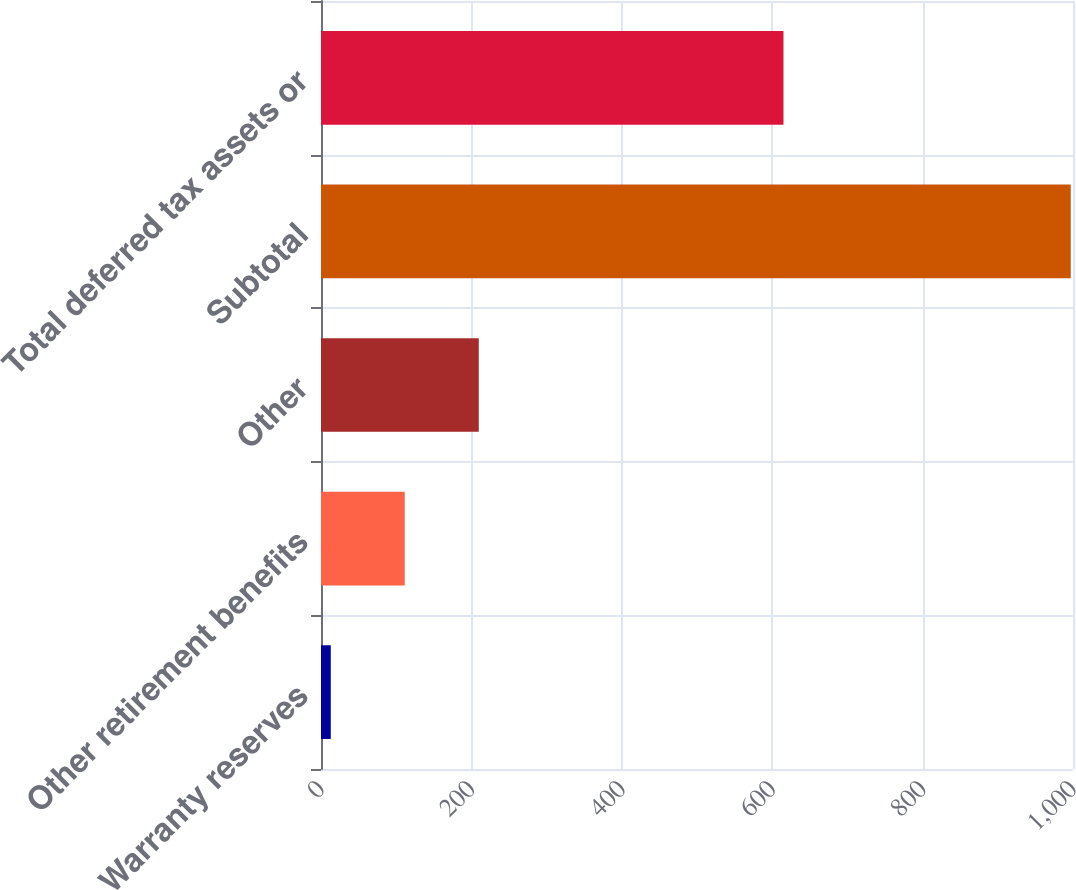<chart> <loc_0><loc_0><loc_500><loc_500><bar_chart><fcel>Warranty reserves<fcel>Other retirement benefits<fcel>Other<fcel>Subtotal<fcel>Total deferred tax assets or<nl><fcel>13<fcel>111.4<fcel>209.8<fcel>997<fcel>615<nl></chart> 